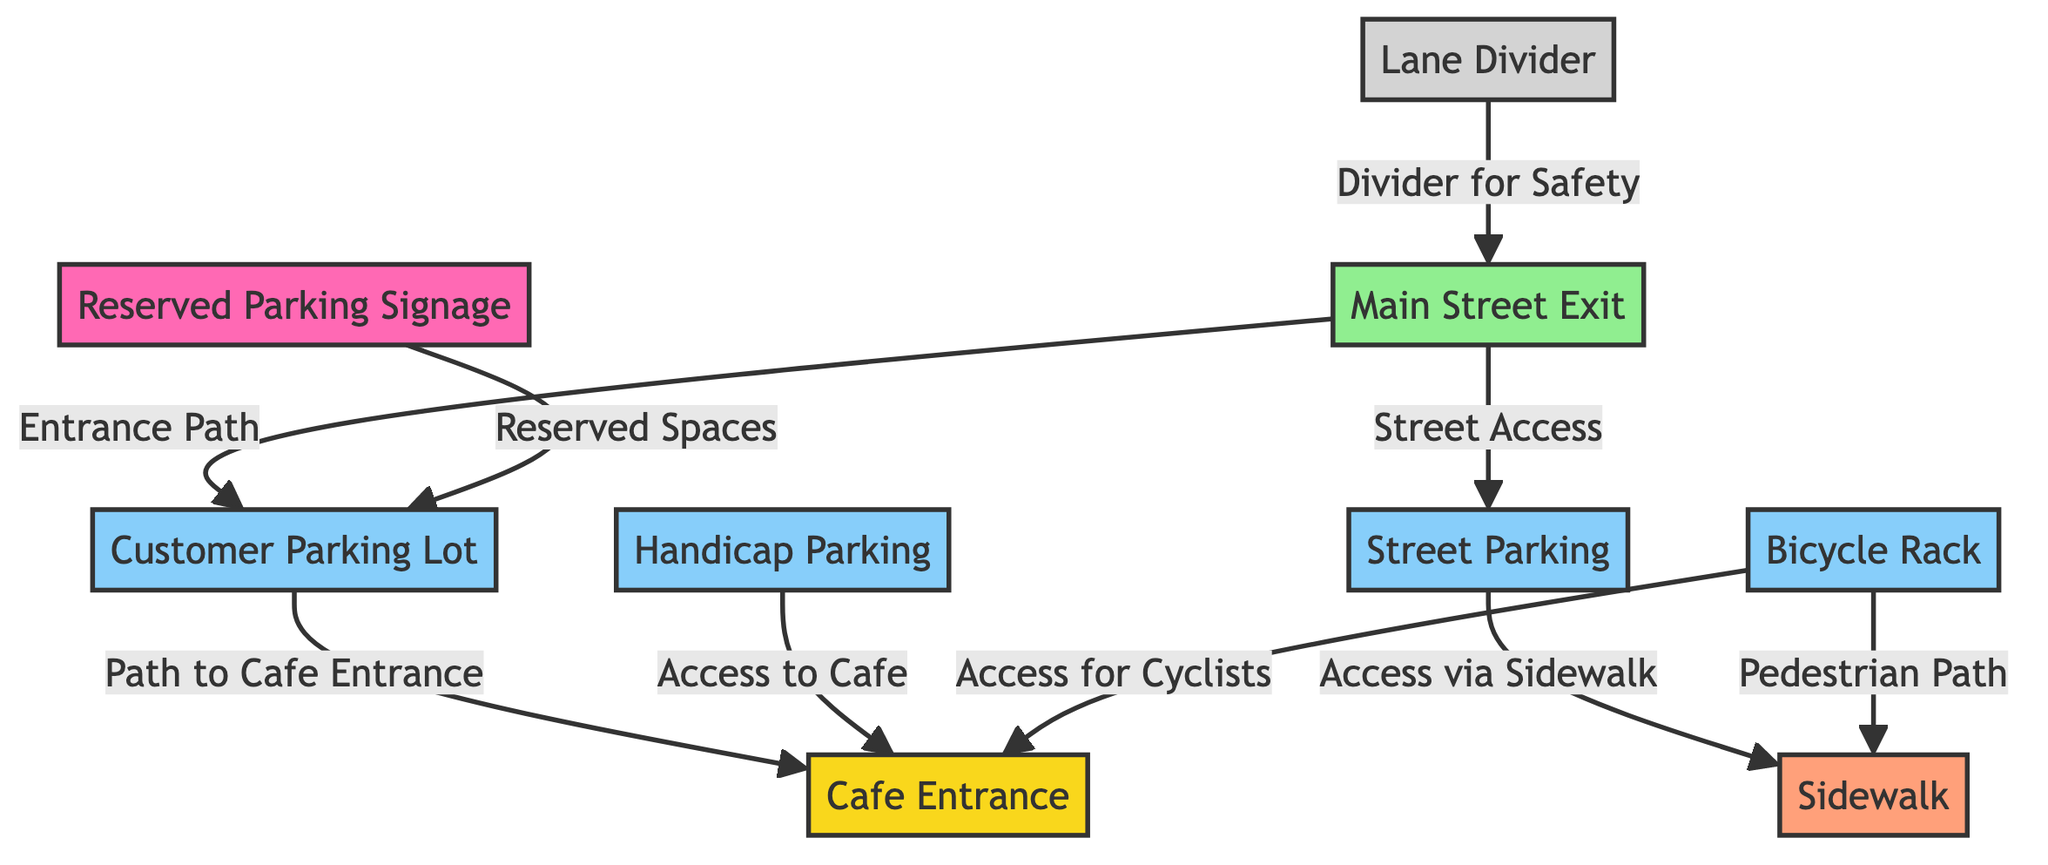What's the total number of nodes in the diagram? There are 9 nodes listed in the diagram: Cafe Entrance, Customer Parking Lot, Street Parking, Handicap Parking, Reserved Parking Signage, Main Street Exit, Lane Divider, Sidewalk, and Bicycle Rack.
Answer: 9 Which node provides access to the Cafe from the Handicap Parking area? The edge connecting the Handicap Parking to the Cafe Entrance indicates that it allows access directly to the Cafe from the Handicap Parking area.
Answer: Cafe Entrance What is the label of the path that connects the Customer Parking Lot to the Cafe Entrance? The edge labeled "Path to Cafe Entrance" connects the nodes Customer Parking Lot and Cafe Entrance, indicating the route patrons would take to reach the Cafe.
Answer: Path to Cafe Entrance From which location can a customer enter the Customer Parking Lot? The Main Street Exit has a direct edge labeled "Entrance Path" connected to the Customer Parking Lot, showing it as an entry point.
Answer: Main Street Exit How many parking options are available in the diagram? There are four parking nodes in the diagram: Customer Parking Lot, Street Parking, Handicap Parking, and Bicycle Rack.
Answer: 4 What is the purpose of the Lane Divider node in the diagram? The Lane Divider node connects to the Main Street Exit with the label "Divider for Safety", indicating its purpose is to enhance safety at the exit.
Answer: Divider for Safety What is the path that cyclists can use to access the Cafe? Cyclists can access the Cafe via the edge connecting the Bicycle Rack to the Cafe Entrance, labeled "Access for Cyclists".
Answer: Access for Cyclists Which node connects Street Parking to the Sidewalk? The edge labeled "Access via Sidewalk" connects Street Parking to the Sidewalk, indicating how customers can access the sidewalk from the street parking.
Answer: Access via Sidewalk What type of signage is indicated in the diagram? The Reserved Parking Signage node is present, showing that there are designated parking spaces reserved for specific purposes in the diagram.
Answer: Reserved Parking Signage 